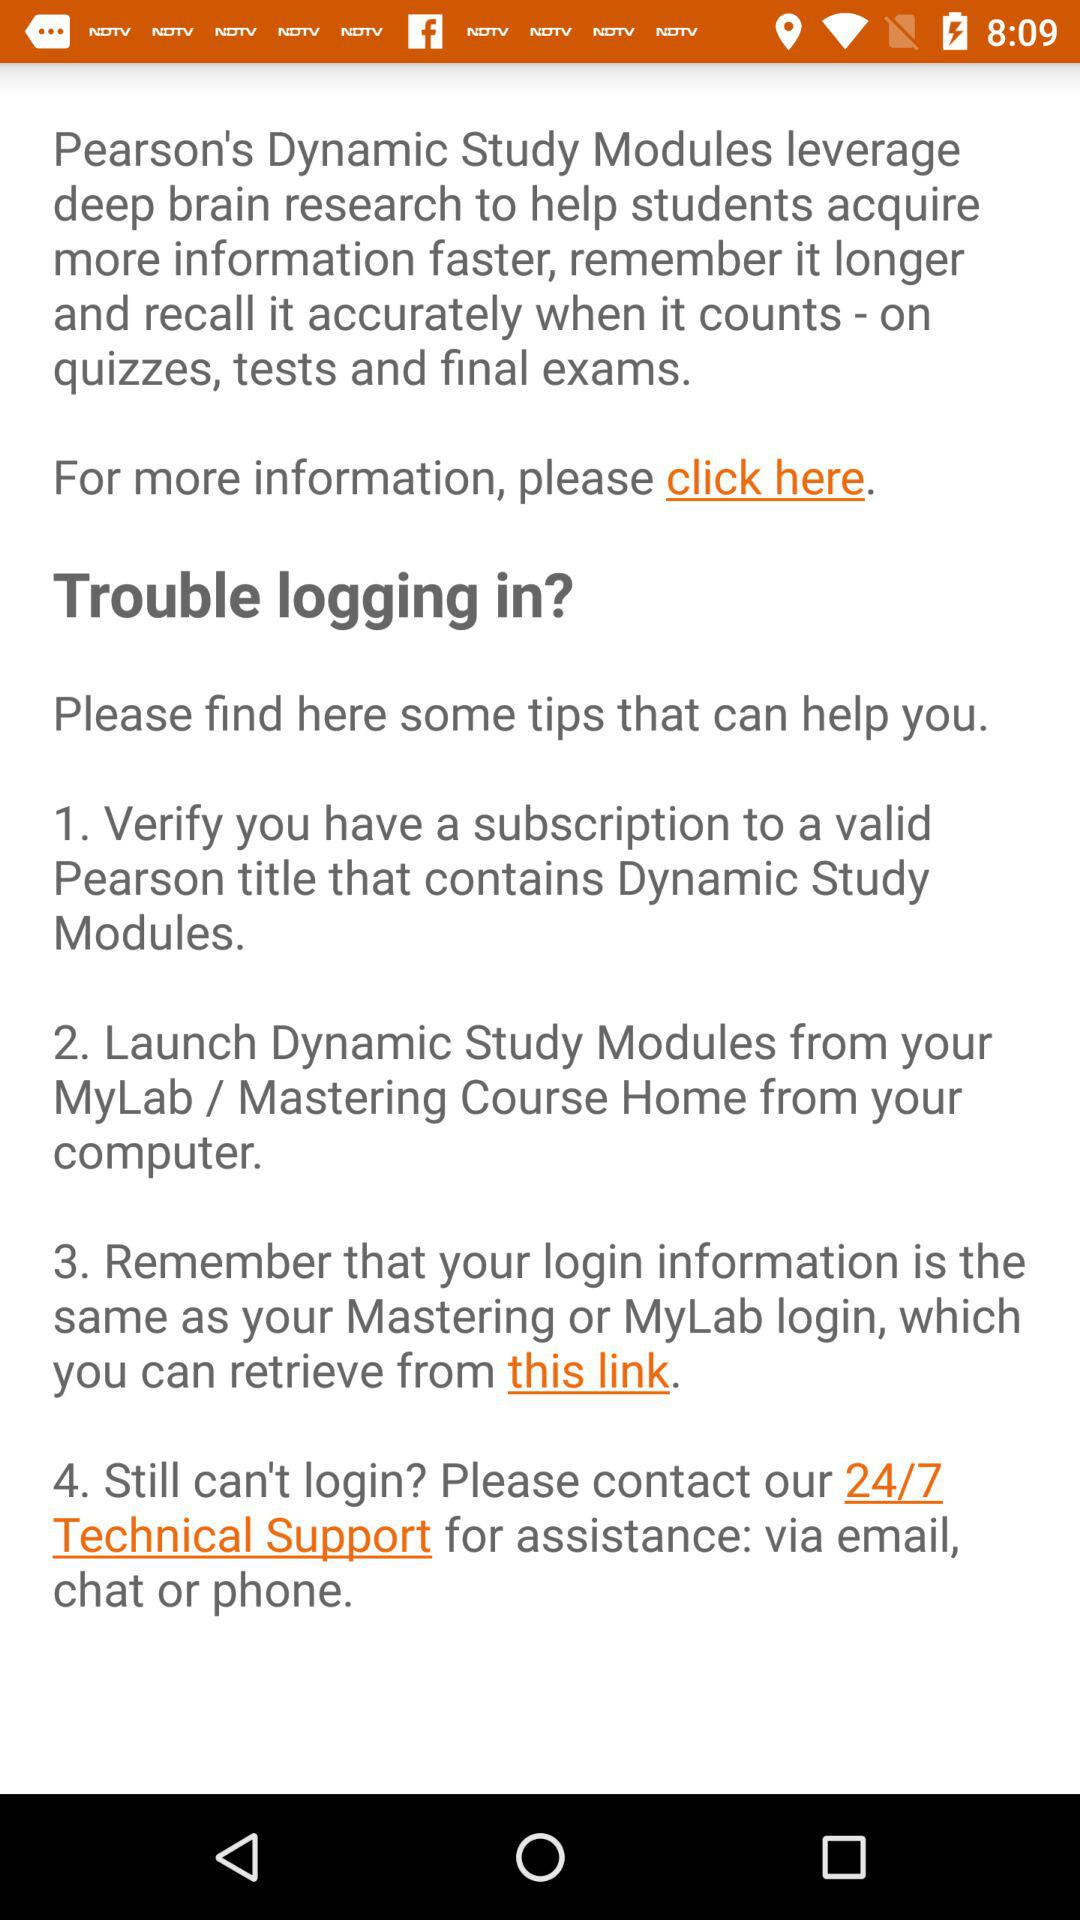How many sections are there in the Dynamic Study Modules help page?
Answer the question using a single word or phrase. 4 